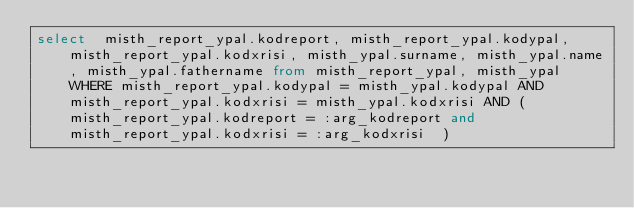Convert code to text. <code><loc_0><loc_0><loc_500><loc_500><_SQL_>select  misth_report_ypal.kodreport, misth_report_ypal.kodypal, misth_report_ypal.kodxrisi, misth_ypal.surname, misth_ypal.name, misth_ypal.fathername from misth_report_ypal, misth_ypal WHERE misth_report_ypal.kodypal = misth_ypal.kodypal AND misth_report_ypal.kodxrisi = misth_ypal.kodxrisi AND ( misth_report_ypal.kodreport = :arg_kodreport and misth_report_ypal.kodxrisi = :arg_kodxrisi  ) </code> 